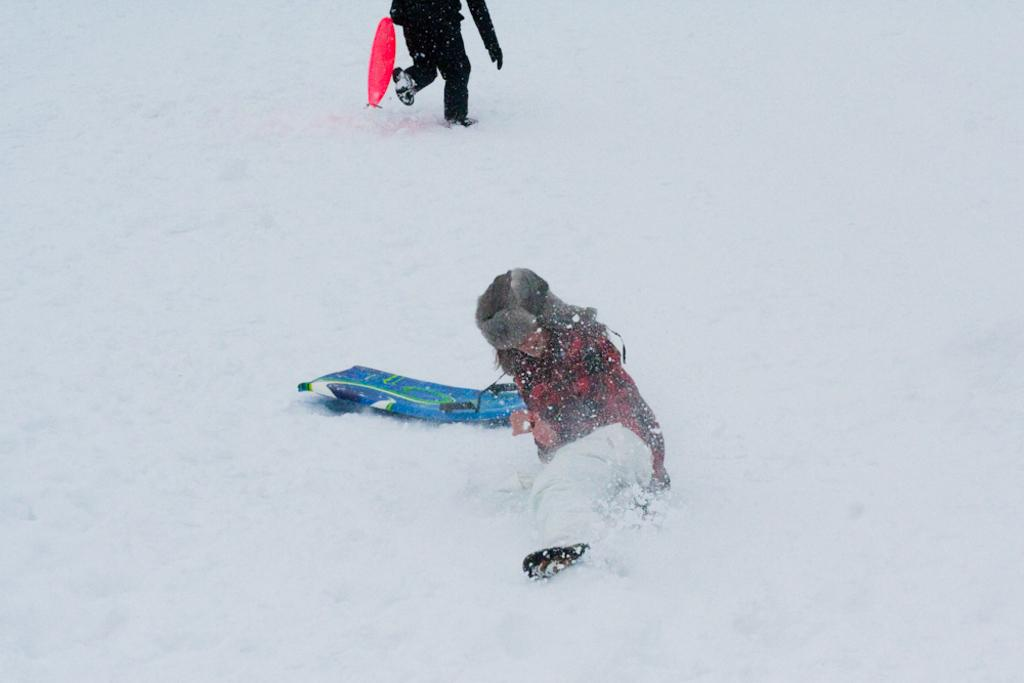What is the person in the image doing on the snow? There is a person lying on the snow in the image. What object is beside the person lying on the snow? There is a skiing board beside the person in the image. What is the other person in the image doing? There is another person running in the image. What type of gun is the person holding while skiing in the image? There is no gun present in the image; the person lying on the snow has a skiing board beside them. 